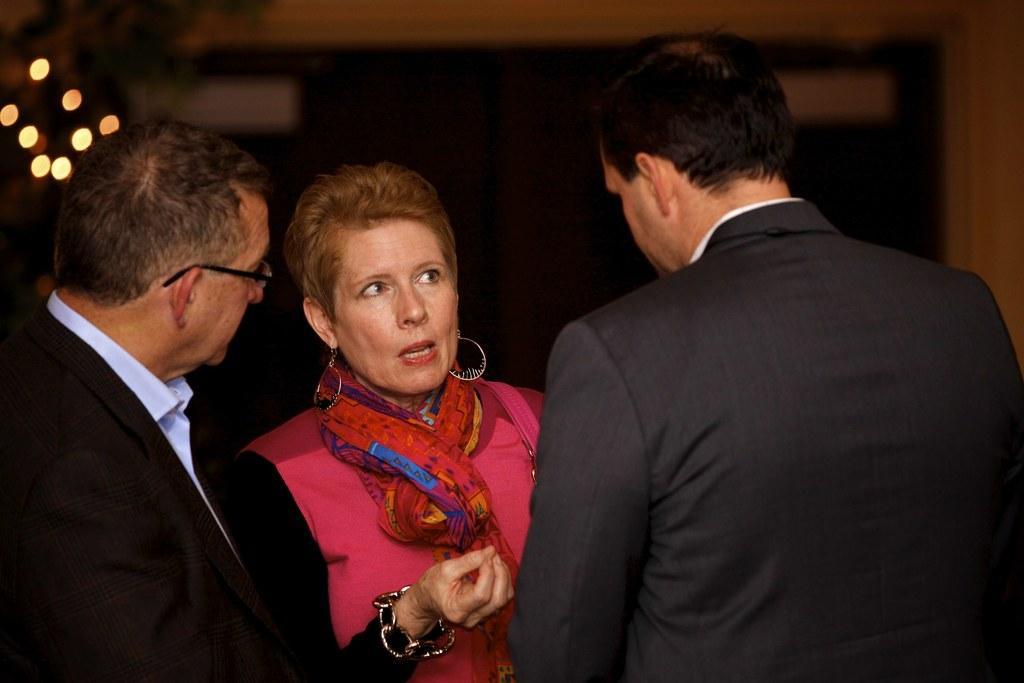How would you summarize this image in a sentence or two? In the center of the image, we can see people standing and one of them is wearing glasses. In the background, there are lights and there is a wall. 